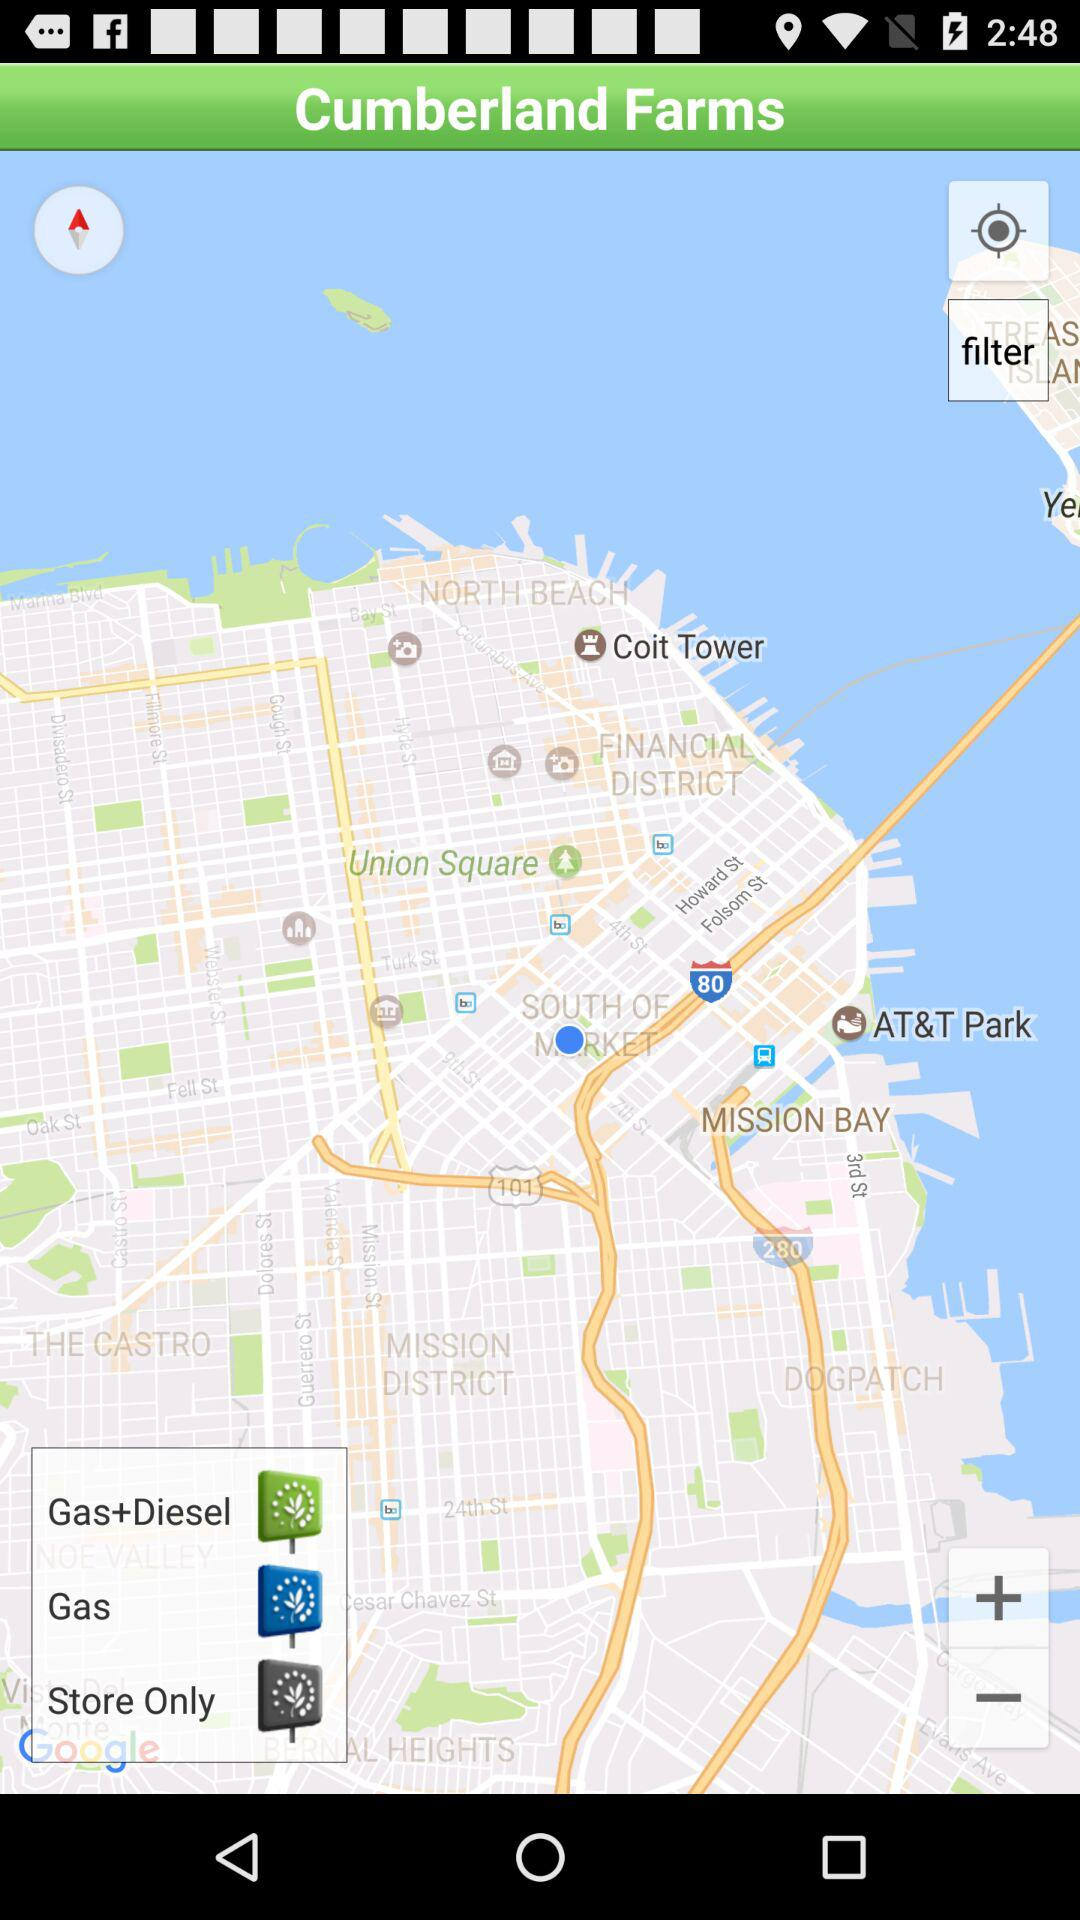How far away is Union Square?
When the provided information is insufficient, respond with <no answer>. <no answer> 